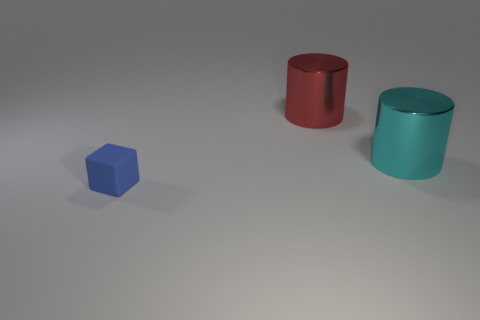Add 3 large brown blocks. How many objects exist? 6 Subtract all blocks. How many objects are left? 2 Subtract all cyan metallic cylinders. Subtract all large cyan metal objects. How many objects are left? 1 Add 2 blue matte objects. How many blue matte objects are left? 3 Add 1 large cyan metal things. How many large cyan metal things exist? 2 Subtract 0 green spheres. How many objects are left? 3 